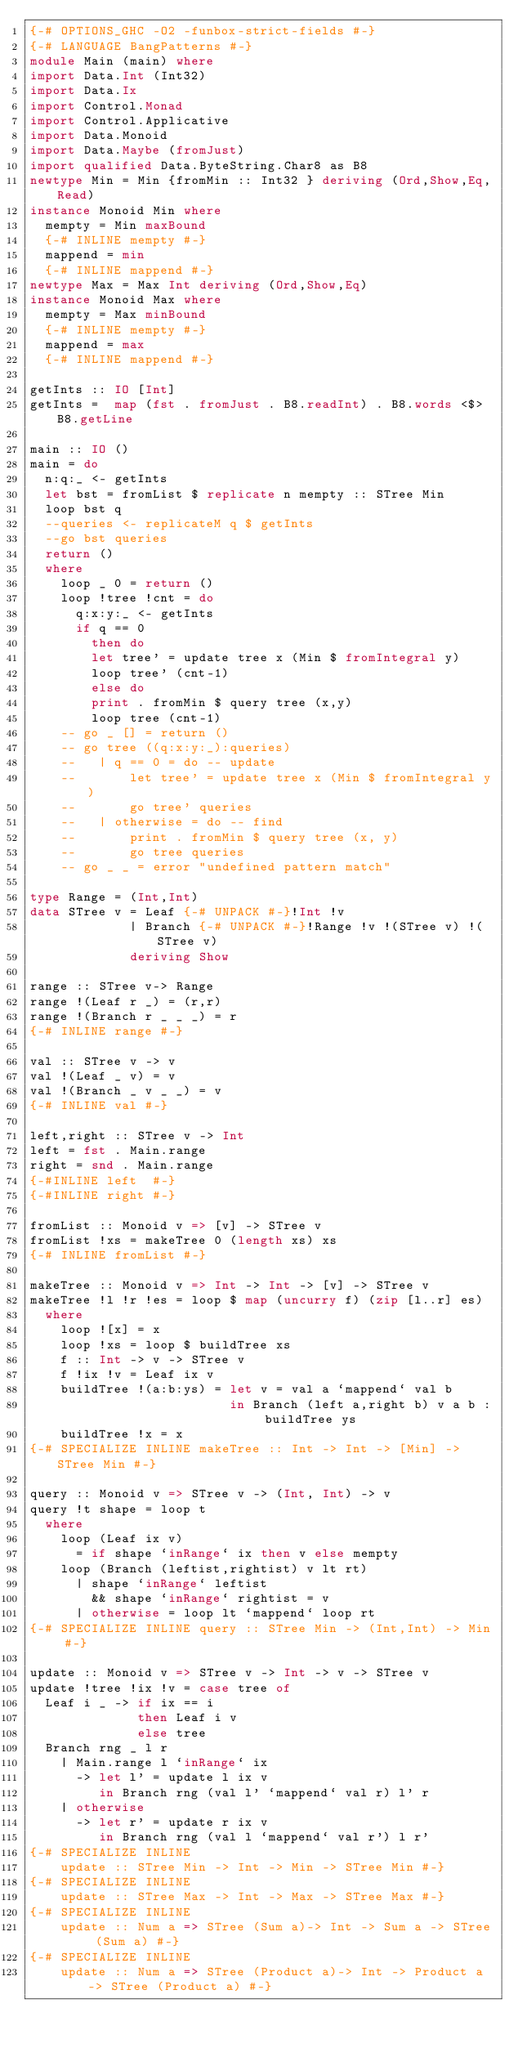<code> <loc_0><loc_0><loc_500><loc_500><_Haskell_>{-# OPTIONS_GHC -O2 -funbox-strict-fields #-}
{-# LANGUAGE BangPatterns #-}
module Main (main) where
import Data.Int (Int32)
import Data.Ix
import Control.Monad
import Control.Applicative
import Data.Monoid
import Data.Maybe (fromJust)
import qualified Data.ByteString.Char8 as B8
newtype Min = Min {fromMin :: Int32 } deriving (Ord,Show,Eq,Read)
instance Monoid Min where
  mempty = Min maxBound
  {-# INLINE mempty #-}
  mappend = min
  {-# INLINE mappend #-}
newtype Max = Max Int deriving (Ord,Show,Eq)
instance Monoid Max where
  mempty = Max minBound
  {-# INLINE mempty #-}
  mappend = max
  {-# INLINE mappend #-}

getInts :: IO [Int]
getInts =  map (fst . fromJust . B8.readInt) . B8.words <$> B8.getLine

main :: IO ()
main = do
  n:q:_ <- getInts
  let bst = fromList $ replicate n mempty :: STree Min
  loop bst q
  --queries <- replicateM q $ getInts
  --go bst queries
  return ()
  where
    loop _ 0 = return ()
    loop !tree !cnt = do
      q:x:y:_ <- getInts
      if q == 0
        then do
        let tree' = update tree x (Min $ fromIntegral y)
        loop tree' (cnt-1)
        else do
        print . fromMin $ query tree (x,y)
        loop tree (cnt-1)
    -- go _ [] = return ()
    -- go tree ((q:x:y:_):queries)
    --   | q == 0 = do -- update
    --       let tree' = update tree x (Min $ fromIntegral y)
    --       go tree' queries
    --   | otherwise = do -- find
    --       print . fromMin $ query tree (x, y)
    --       go tree queries
    -- go _ _ = error "undefined pattern match"

type Range = (Int,Int)
data STree v = Leaf {-# UNPACK #-}!Int !v
             | Branch {-# UNPACK #-}!Range !v !(STree v) !(STree v)
             deriving Show

range :: STree v-> Range
range !(Leaf r _) = (r,r)
range !(Branch r _ _ _) = r
{-# INLINE range #-}

val :: STree v -> v
val !(Leaf _ v) = v
val !(Branch _ v _ _) = v
{-# INLINE val #-}

left,right :: STree v -> Int
left = fst . Main.range
right = snd . Main.range
{-#INLINE left  #-}
{-#INLINE right #-}

fromList :: Monoid v => [v] -> STree v
fromList !xs = makeTree 0 (length xs) xs
{-# INLINE fromList #-}

makeTree :: Monoid v => Int -> Int -> [v] -> STree v
makeTree !l !r !es = loop $ map (uncurry f) (zip [l..r] es)
  where
    loop ![x] = x
    loop !xs = loop $ buildTree xs
    f :: Int -> v -> STree v
    f !ix !v = Leaf ix v
    buildTree !(a:b:ys) = let v = val a `mappend` val b
                          in Branch (left a,right b) v a b : buildTree ys
    buildTree !x = x
{-# SPECIALIZE INLINE makeTree :: Int -> Int -> [Min] -> STree Min #-}

query :: Monoid v => STree v -> (Int, Int) -> v
query !t shape = loop t
  where
    loop (Leaf ix v)
      = if shape `inRange` ix then v else mempty
    loop (Branch (leftist,rightist) v lt rt)
      | shape `inRange` leftist
        && shape `inRange` rightist = v
      | otherwise = loop lt `mappend` loop rt
{-# SPECIALIZE INLINE query :: STree Min -> (Int,Int) -> Min #-}

update :: Monoid v => STree v -> Int -> v -> STree v
update !tree !ix !v = case tree of
  Leaf i _ -> if ix == i
              then Leaf i v
              else tree
  Branch rng _ l r
    | Main.range l `inRange` ix
      -> let l' = update l ix v
         in Branch rng (val l' `mappend` val r) l' r
    | otherwise
      -> let r' = update r ix v
         in Branch rng (val l `mappend` val r') l r'
{-# SPECIALIZE INLINE
    update :: STree Min -> Int -> Min -> STree Min #-}
{-# SPECIALIZE INLINE
    update :: STree Max -> Int -> Max -> STree Max #-}
{-# SPECIALIZE INLINE
    update :: Num a => STree (Sum a)-> Int -> Sum a -> STree (Sum a) #-}
{-# SPECIALIZE INLINE
    update :: Num a => STree (Product a)-> Int -> Product a -> STree (Product a) #-}</code> 